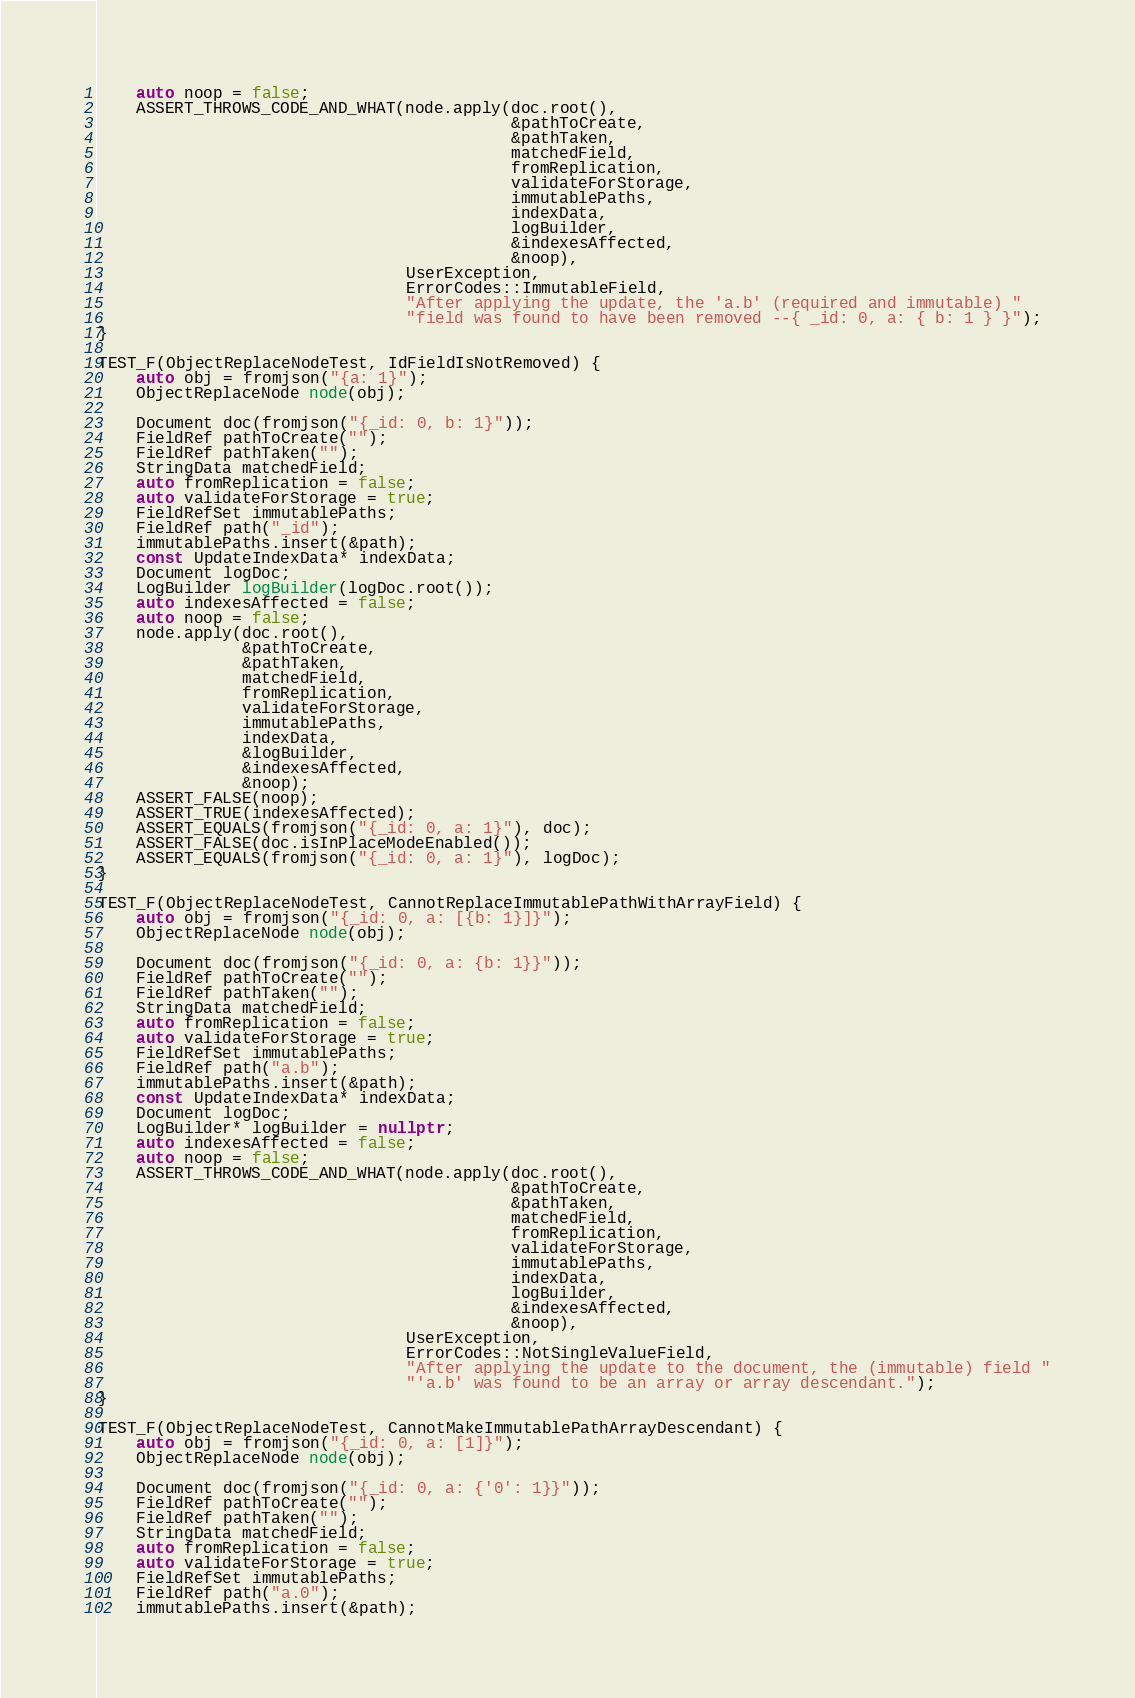Convert code to text. <code><loc_0><loc_0><loc_500><loc_500><_C++_>    auto noop = false;
    ASSERT_THROWS_CODE_AND_WHAT(node.apply(doc.root(),
                                           &pathToCreate,
                                           &pathTaken,
                                           matchedField,
                                           fromReplication,
                                           validateForStorage,
                                           immutablePaths,
                                           indexData,
                                           logBuilder,
                                           &indexesAffected,
                                           &noop),
                                UserException,
                                ErrorCodes::ImmutableField,
                                "After applying the update, the 'a.b' (required and immutable) "
                                "field was found to have been removed --{ _id: 0, a: { b: 1 } }");
}

TEST_F(ObjectReplaceNodeTest, IdFieldIsNotRemoved) {
    auto obj = fromjson("{a: 1}");
    ObjectReplaceNode node(obj);

    Document doc(fromjson("{_id: 0, b: 1}"));
    FieldRef pathToCreate("");
    FieldRef pathTaken("");
    StringData matchedField;
    auto fromReplication = false;
    auto validateForStorage = true;
    FieldRefSet immutablePaths;
    FieldRef path("_id");
    immutablePaths.insert(&path);
    const UpdateIndexData* indexData;
    Document logDoc;
    LogBuilder logBuilder(logDoc.root());
    auto indexesAffected = false;
    auto noop = false;
    node.apply(doc.root(),
               &pathToCreate,
               &pathTaken,
               matchedField,
               fromReplication,
               validateForStorage,
               immutablePaths,
               indexData,
               &logBuilder,
               &indexesAffected,
               &noop);
    ASSERT_FALSE(noop);
    ASSERT_TRUE(indexesAffected);
    ASSERT_EQUALS(fromjson("{_id: 0, a: 1}"), doc);
    ASSERT_FALSE(doc.isInPlaceModeEnabled());
    ASSERT_EQUALS(fromjson("{_id: 0, a: 1}"), logDoc);
}

TEST_F(ObjectReplaceNodeTest, CannotReplaceImmutablePathWithArrayField) {
    auto obj = fromjson("{_id: 0, a: [{b: 1}]}");
    ObjectReplaceNode node(obj);

    Document doc(fromjson("{_id: 0, a: {b: 1}}"));
    FieldRef pathToCreate("");
    FieldRef pathTaken("");
    StringData matchedField;
    auto fromReplication = false;
    auto validateForStorage = true;
    FieldRefSet immutablePaths;
    FieldRef path("a.b");
    immutablePaths.insert(&path);
    const UpdateIndexData* indexData;
    Document logDoc;
    LogBuilder* logBuilder = nullptr;
    auto indexesAffected = false;
    auto noop = false;
    ASSERT_THROWS_CODE_AND_WHAT(node.apply(doc.root(),
                                           &pathToCreate,
                                           &pathTaken,
                                           matchedField,
                                           fromReplication,
                                           validateForStorage,
                                           immutablePaths,
                                           indexData,
                                           logBuilder,
                                           &indexesAffected,
                                           &noop),
                                UserException,
                                ErrorCodes::NotSingleValueField,
                                "After applying the update to the document, the (immutable) field "
                                "'a.b' was found to be an array or array descendant.");
}

TEST_F(ObjectReplaceNodeTest, CannotMakeImmutablePathArrayDescendant) {
    auto obj = fromjson("{_id: 0, a: [1]}");
    ObjectReplaceNode node(obj);

    Document doc(fromjson("{_id: 0, a: {'0': 1}}"));
    FieldRef pathToCreate("");
    FieldRef pathTaken("");
    StringData matchedField;
    auto fromReplication = false;
    auto validateForStorage = true;
    FieldRefSet immutablePaths;
    FieldRef path("a.0");
    immutablePaths.insert(&path);</code> 